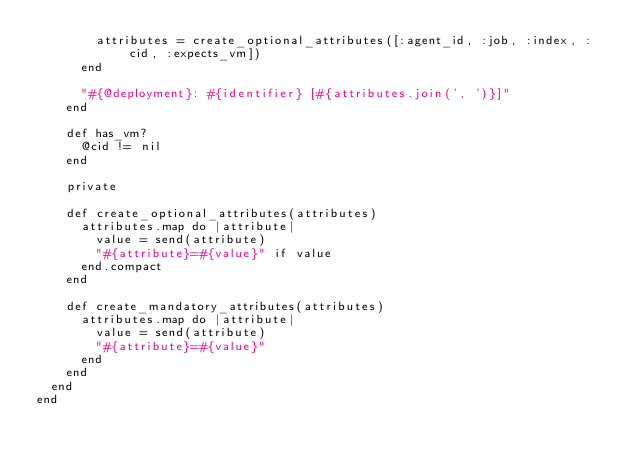Convert code to text. <code><loc_0><loc_0><loc_500><loc_500><_Ruby_>        attributes = create_optional_attributes([:agent_id, :job, :index, :cid, :expects_vm])
      end

      "#{@deployment}: #{identifier} [#{attributes.join(', ')}]"
    end

    def has_vm?
      @cid != nil
    end

    private

    def create_optional_attributes(attributes)
      attributes.map do |attribute|
        value = send(attribute)
        "#{attribute}=#{value}" if value
      end.compact
    end

    def create_mandatory_attributes(attributes)
      attributes.map do |attribute|
        value = send(attribute)
        "#{attribute}=#{value}"
      end
    end
  end
end
</code> 